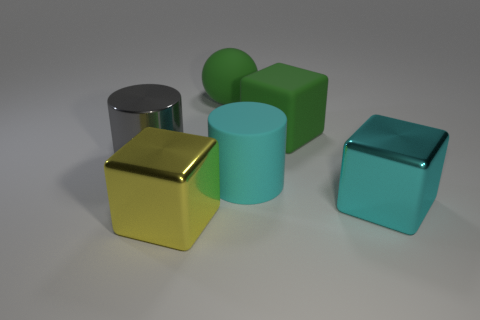There is a big rubber thing that is to the left of the rubber cylinder; what is its color?
Keep it short and to the point. Green. Is the number of shiny cylinders in front of the big cyan cube greater than the number of green spheres on the right side of the cyan cylinder?
Your answer should be compact. No. How big is the cyan shiny cube in front of the matte object that is in front of the big cylinder that is left of the large green ball?
Provide a short and direct response. Large. Is there a cylinder of the same color as the rubber cube?
Offer a very short reply. No. How many big cylinders are there?
Ensure brevity in your answer.  2. The thing that is behind the cube that is behind the cyan object that is to the right of the green block is made of what material?
Give a very brief answer. Rubber. Is there a blue cylinder that has the same material as the cyan cylinder?
Keep it short and to the point. No. Does the yellow thing have the same material as the green sphere?
Make the answer very short. No. What number of cubes are either large shiny things or cyan things?
Offer a very short reply. 2. What color is the big cylinder that is the same material as the large green ball?
Provide a short and direct response. Cyan. 